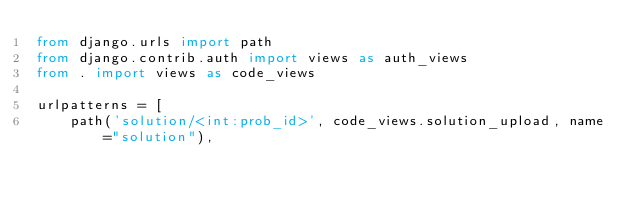<code> <loc_0><loc_0><loc_500><loc_500><_Python_>from django.urls import path
from django.contrib.auth import views as auth_views
from . import views as code_views

urlpatterns = [
    path('solution/<int:prob_id>', code_views.solution_upload, name="solution"),</code> 